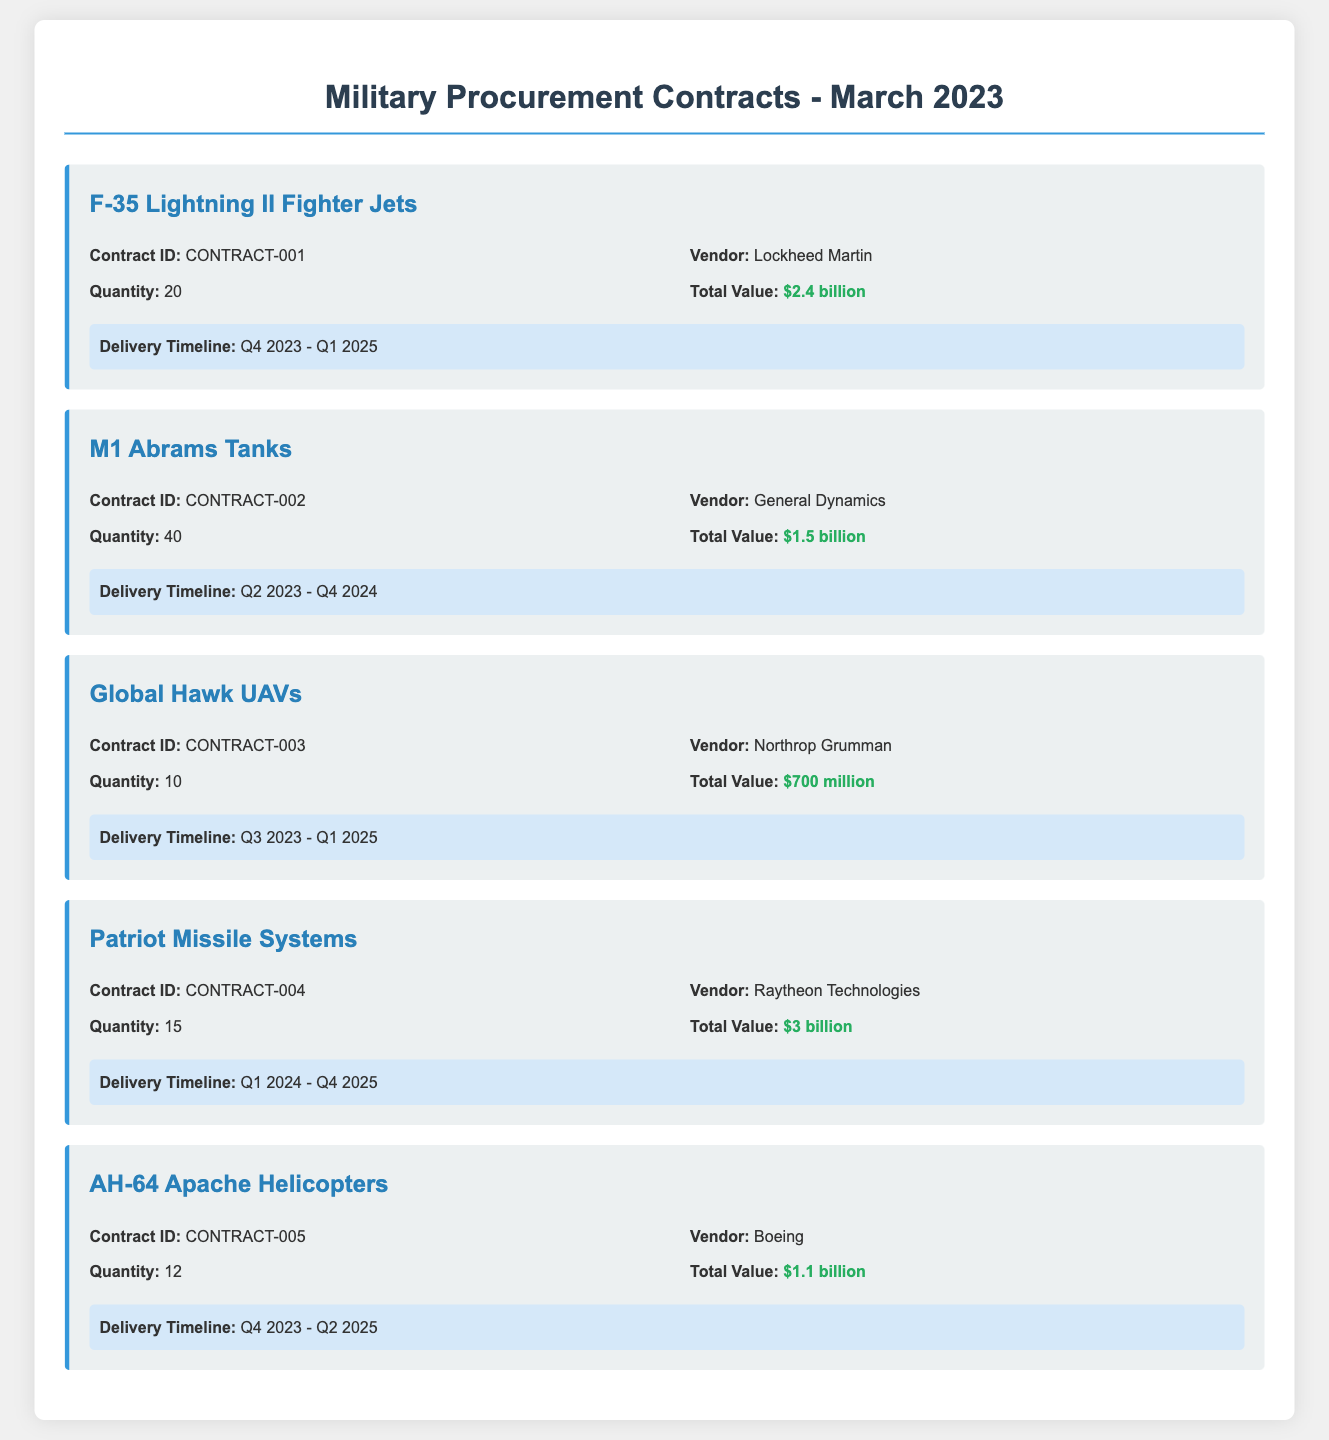What is the total value of the F-35 Lightning II Fighter Jets contract? The total value for the F-35 Lightning II Fighter Jets is specifically mentioned in the contract details as $2.4 billion.
Answer: $2.4 billion How many M1 Abrams Tanks are included in the contract? The quantity of M1 Abrams Tanks in the contract is explicitly listed as 40 in the contract details.
Answer: 40 Who is the vendor for the Global Hawk UAVs? The vendor for the Global Hawk UAVs is clearly stated as Northrop Grumman in the document.
Answer: Northrop Grumman What is the delivery timeline for the Patriot Missile Systems? The delivery timeline for the Patriot Missile Systems is provided as Q1 2024 - Q4 2025 in the document.
Answer: Q1 2024 - Q4 2025 Which equipment has the highest total value among the contracts? By comparing the total values provided in each contract, the Patriot Missile Systems' total value of $3 billion is the highest.
Answer: $3 billion What is the contract ID for the AH-64 Apache Helicopters? Each contract is associated with a unique contract ID, with the AH-64 Apache Helicopters having the ID CONTRACT-005.
Answer: CONTRACT-005 What is the quantity of F-35 Lightning II Fighter Jets being procured? The quantity listed for the F-35 Lightning II Fighter Jets is 20 as indicated in the contract details.
Answer: 20 Which vendor is responsible for the M1 Abrams Tanks? The vendor responsible for the M1 Abrams Tanks is clearly mentioned in the contract as General Dynamics.
Answer: General Dynamics In which quarter is the delivery of the Global Hawk UAVs expected to begin? The delivery timeline indicates that the Global Hawk UAVs are expected to begin delivery in Q3 2023.
Answer: Q3 2023 